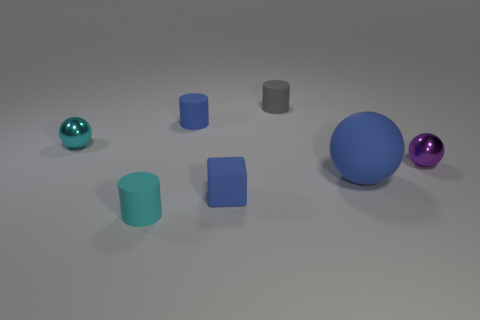Add 3 balls. How many objects exist? 10 Subtract all small blue cylinders. How many cylinders are left? 2 Subtract all large purple metallic spheres. Subtract all tiny purple things. How many objects are left? 6 Add 1 gray matte things. How many gray matte things are left? 2 Add 5 purple blocks. How many purple blocks exist? 5 Subtract all purple spheres. How many spheres are left? 2 Subtract 1 purple spheres. How many objects are left? 6 Subtract all cylinders. How many objects are left? 4 Subtract 1 blocks. How many blocks are left? 0 Subtract all yellow cylinders. Subtract all brown balls. How many cylinders are left? 3 